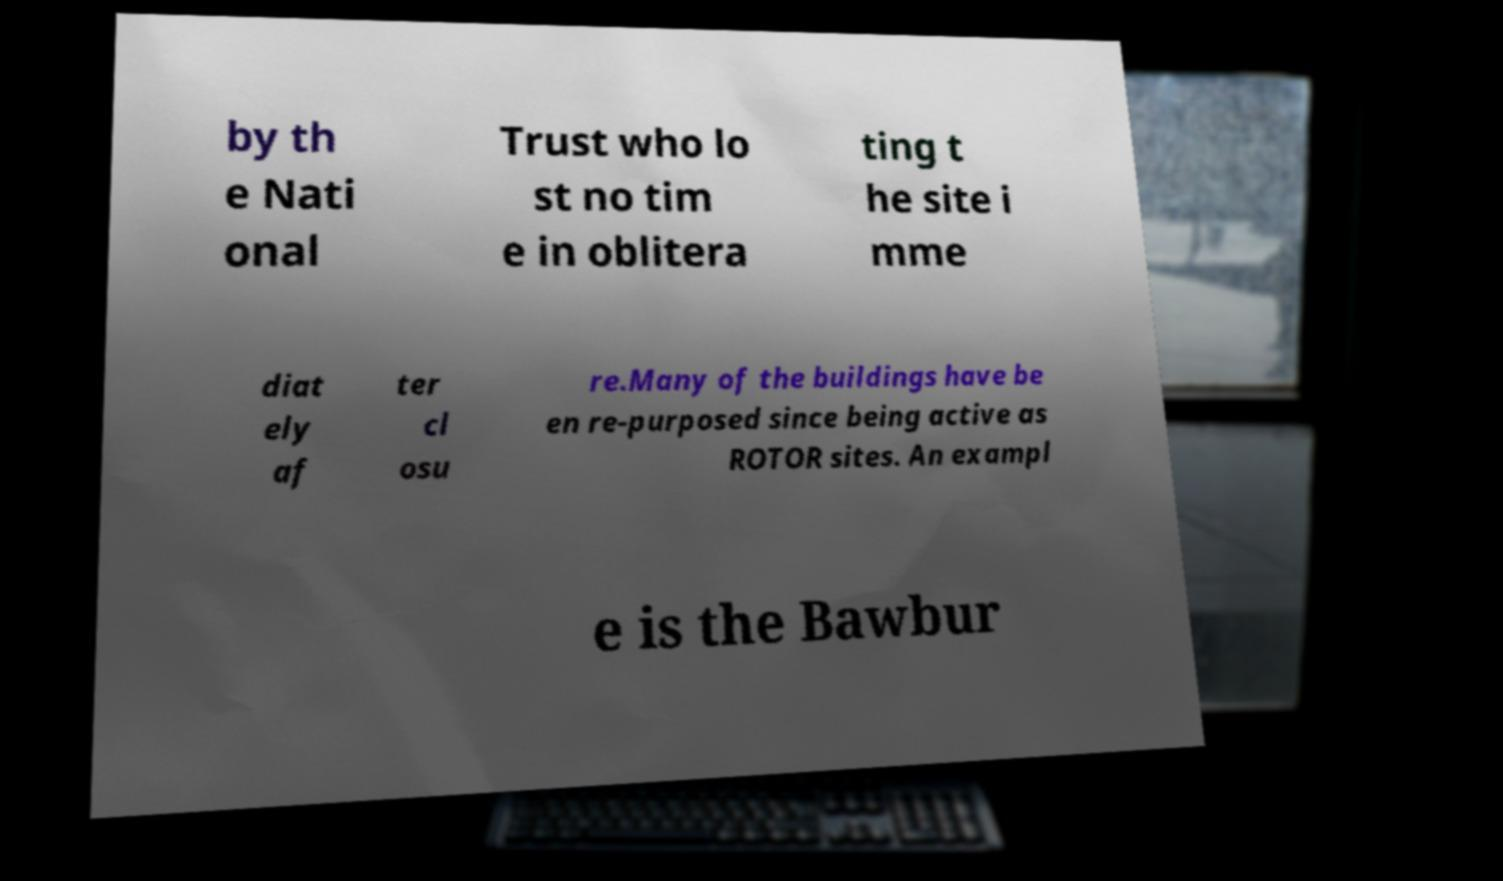What messages or text are displayed in this image? I need them in a readable, typed format. by th e Nati onal Trust who lo st no tim e in oblitera ting t he site i mme diat ely af ter cl osu re.Many of the buildings have be en re-purposed since being active as ROTOR sites. An exampl e is the Bawbur 